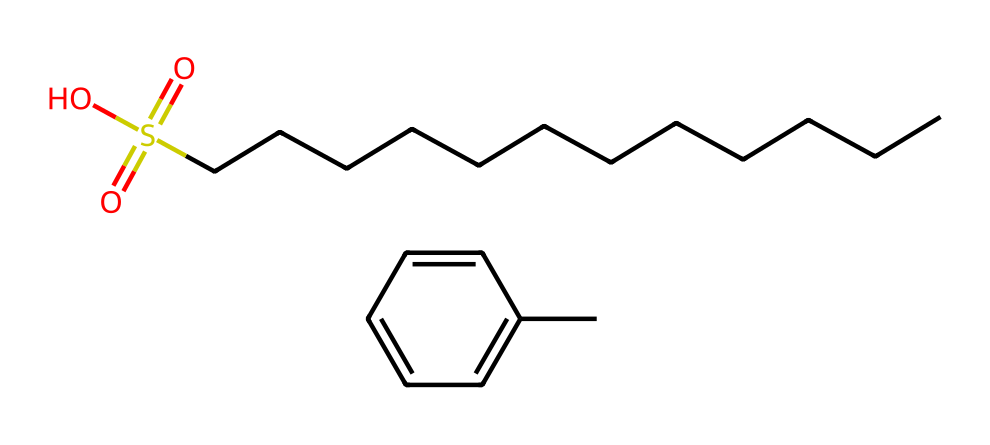What is the main functional group in this structure? The structure contains a sulfonate group (–SO3) indicated by the presence of sulfur and three oxygens connected to it. This functional group is key in identifying the chemical properties of alkylbenzene sulfonate.
Answer: sulfonate How many carbon atoms are in the alkyl chain? By counting the "C" in the linear chain towards the left, there are 12 carbon atoms represented in the alkyl part of alkylbenzene sulfonate.
Answer: 12 What is the role of the aromatic ring in this chemical? The aromatic ring provides stability and hydrophobic properties, allowing the molecule to interact effectively with both water and oils, which makes it suitable for a detergent.
Answer: stability How many total oxygen atoms are present? In the SMILES notation, there are 4 oxygen atoms indicated (three from the sulfonate group and one as a hydroxyl). Therefore, the total count is four oxygen atoms.
Answer: 4 What type of detergent does alkylbenzene sulfonate classify as? Alkylbenzene sulfonate is classified as an anionic detergent, primarily used in cleaning products due to its effectiveness in removing dirt and grease.
Answer: anionic What characteristic of this detergent contributes to its cleaning power? The negatively charged sulfonate group increases the detergent's ability to interact with and emulsify grease and oils, enhancing its cleaning efficiency.
Answer: emulsification 